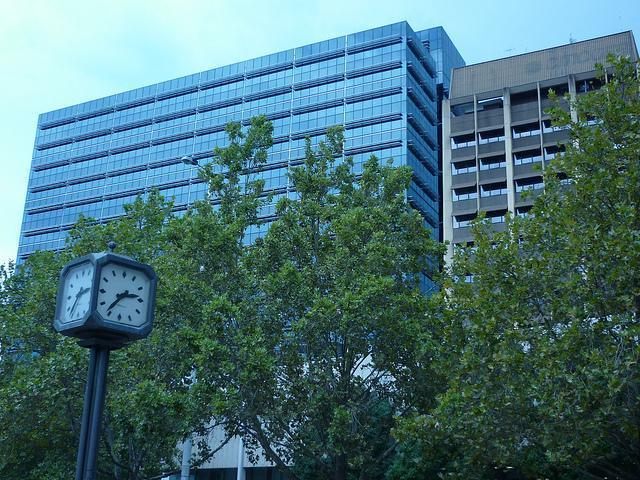How many clock faces are shown?
Give a very brief answer. 2. How many people in the audience are wearing a yellow jacket?
Give a very brief answer. 0. 